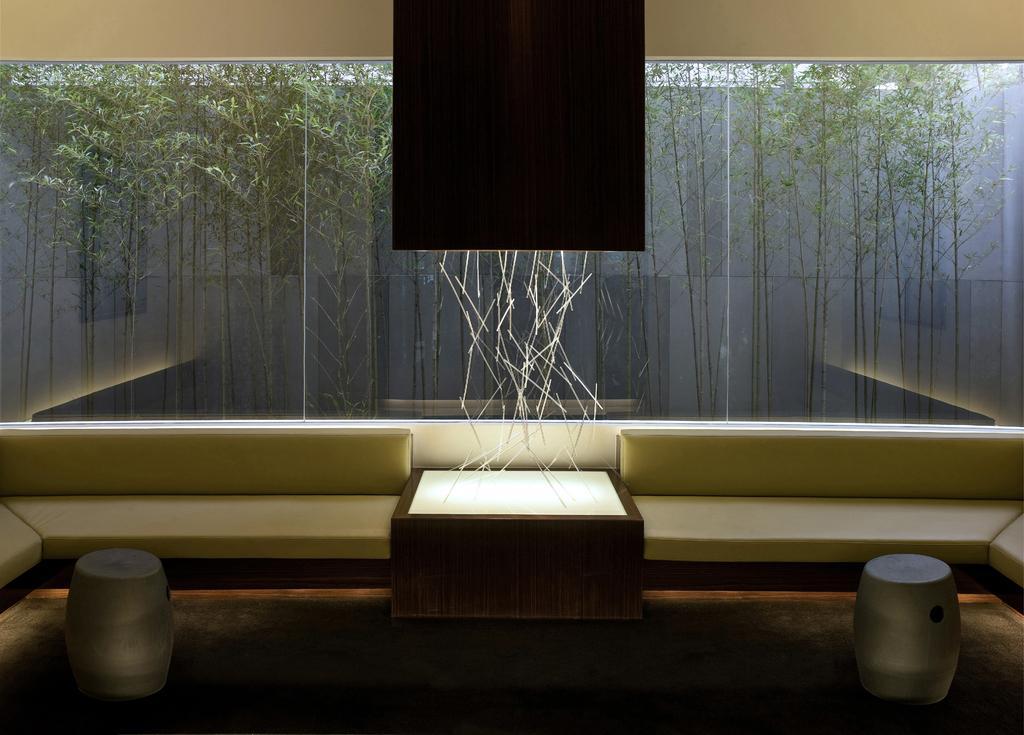How would you summarize this image in a sentence or two? It is a living room inside the house there are two sofas in between there is a table on the table that is LED light with some decorative items, in the background there is a glass behind the glass there are some trees. 